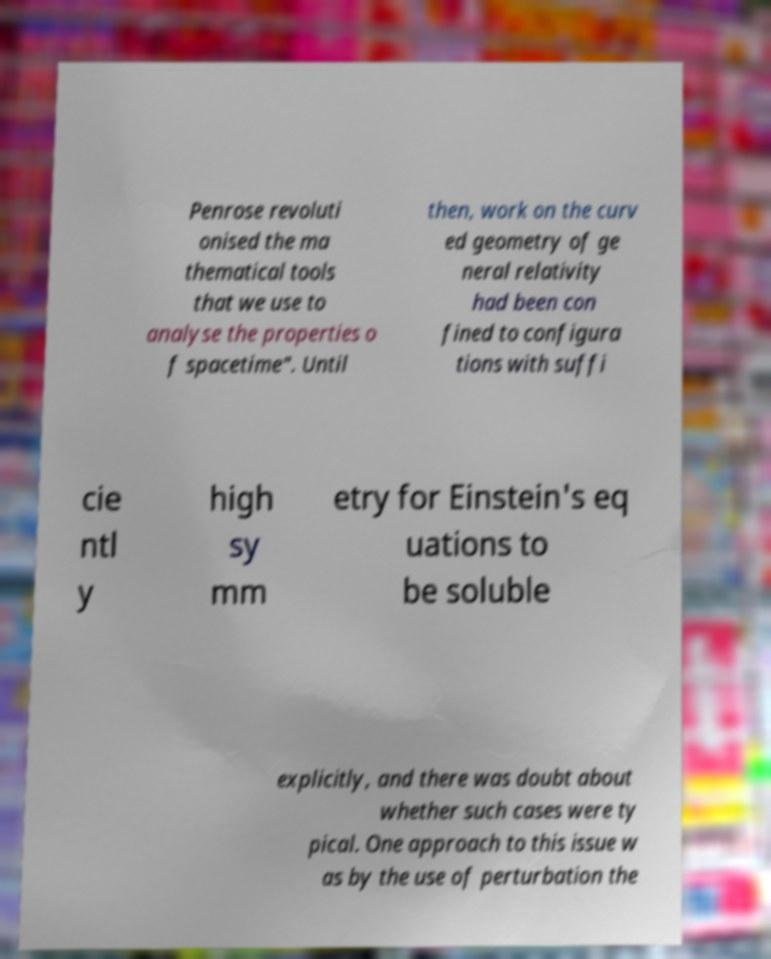Please identify and transcribe the text found in this image. Penrose revoluti onised the ma thematical tools that we use to analyse the properties o f spacetime". Until then, work on the curv ed geometry of ge neral relativity had been con fined to configura tions with suffi cie ntl y high sy mm etry for Einstein's eq uations to be soluble explicitly, and there was doubt about whether such cases were ty pical. One approach to this issue w as by the use of perturbation the 